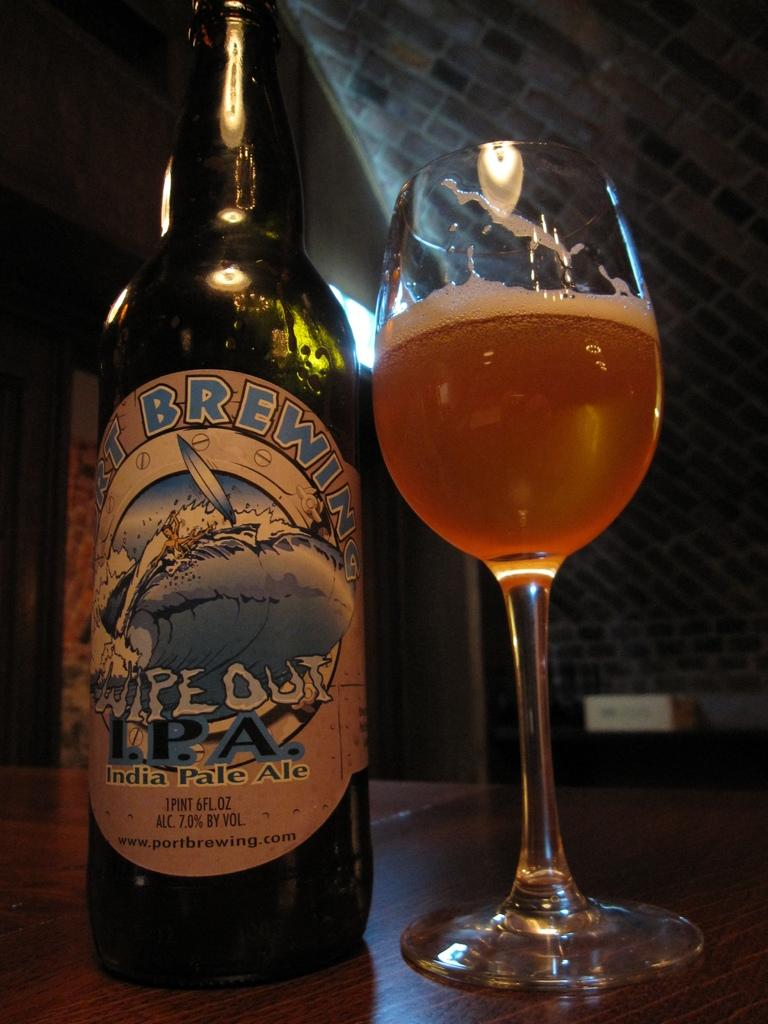<image>
Share a concise interpretation of the image provided. A bottle of Wipe Out IPA is poured out into a glass on the table. 